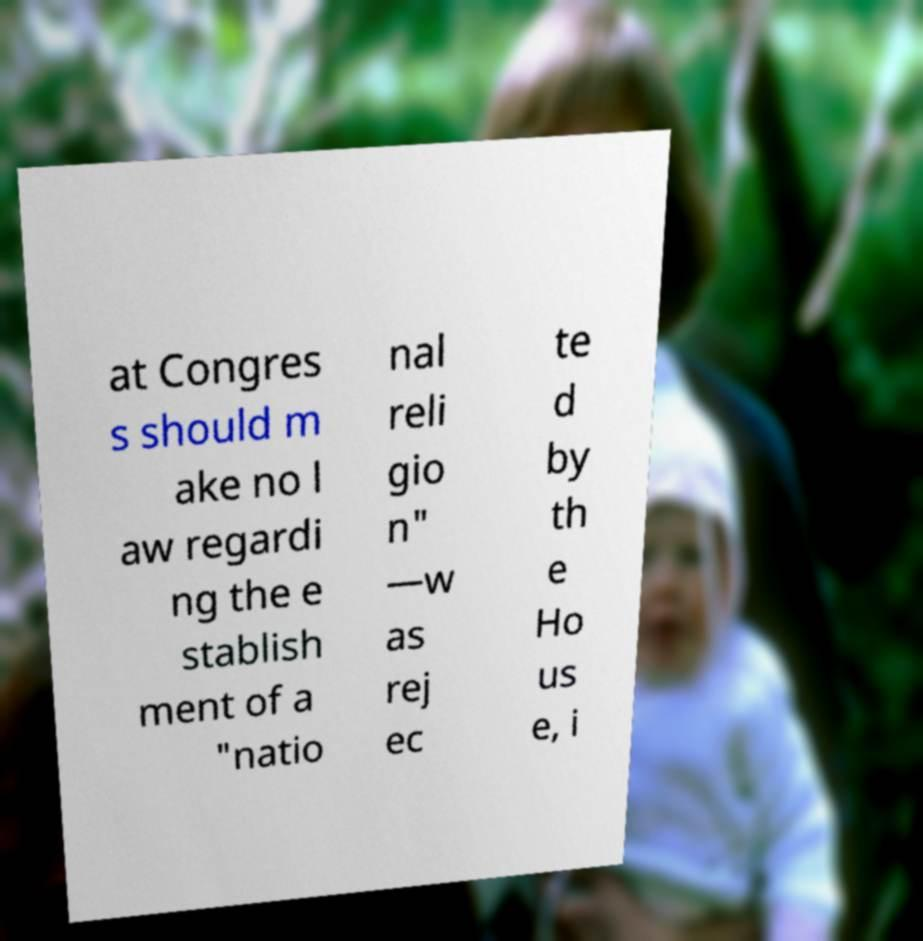Please read and relay the text visible in this image. What does it say? at Congres s should m ake no l aw regardi ng the e stablish ment of a "natio nal reli gio n" —w as rej ec te d by th e Ho us e, i 